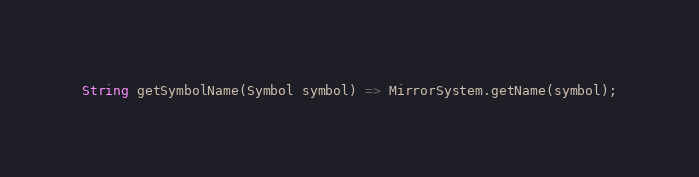<code> <loc_0><loc_0><loc_500><loc_500><_Dart_>String getSymbolName(Symbol symbol) => MirrorSystem.getName(symbol);
</code> 